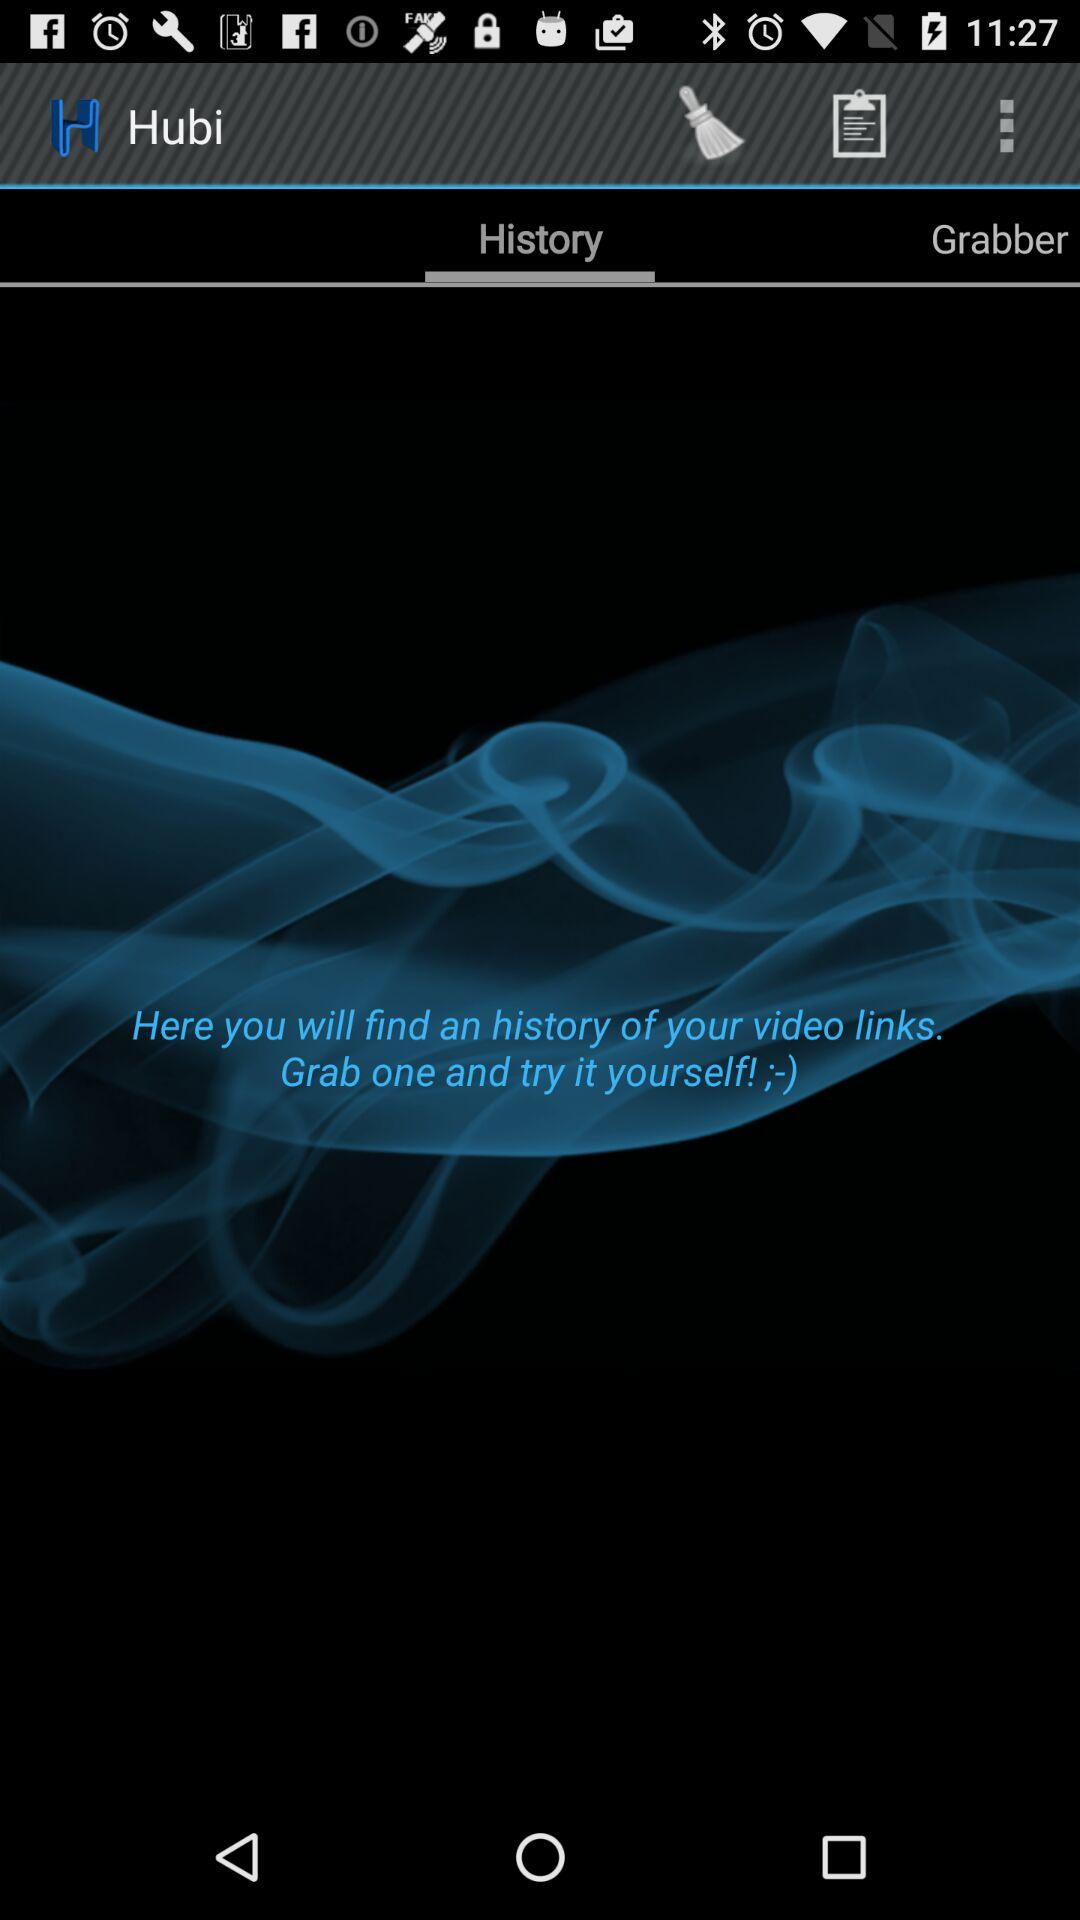Which tab is selected? The selected tab is "History". 